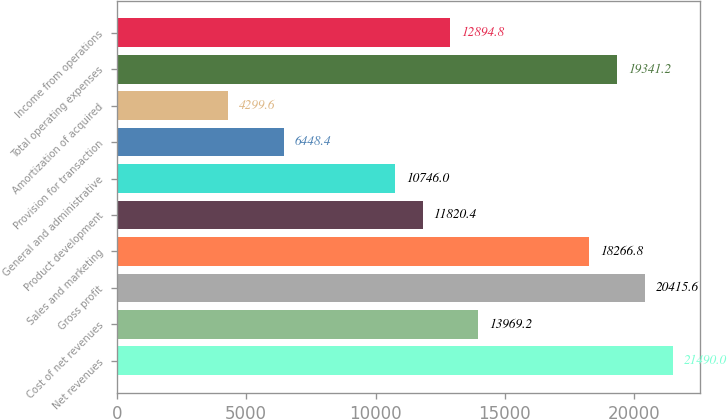<chart> <loc_0><loc_0><loc_500><loc_500><bar_chart><fcel>Net revenues<fcel>Cost of net revenues<fcel>Gross profit<fcel>Sales and marketing<fcel>Product development<fcel>General and administrative<fcel>Provision for transaction<fcel>Amortization of acquired<fcel>Total operating expenses<fcel>Income from operations<nl><fcel>21490<fcel>13969.2<fcel>20415.6<fcel>18266.8<fcel>11820.4<fcel>10746<fcel>6448.4<fcel>4299.6<fcel>19341.2<fcel>12894.8<nl></chart> 